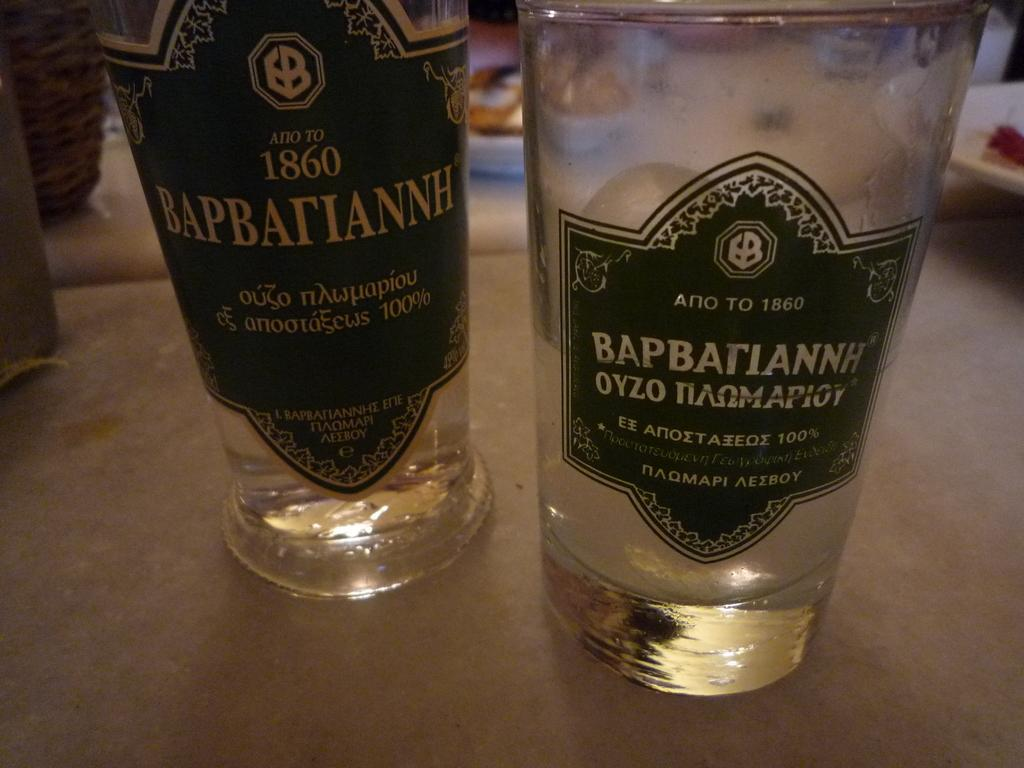What is on the label of the bottle in the image? The facts provided do not specify what is on the label of the bottle. Where is the bottle located in the image? The bottle is on a table in the image. What else is on the table in the image? There is a glass on the table in the image. How many children are playing with the cloth in the image? There are no children or cloth present in the image. 